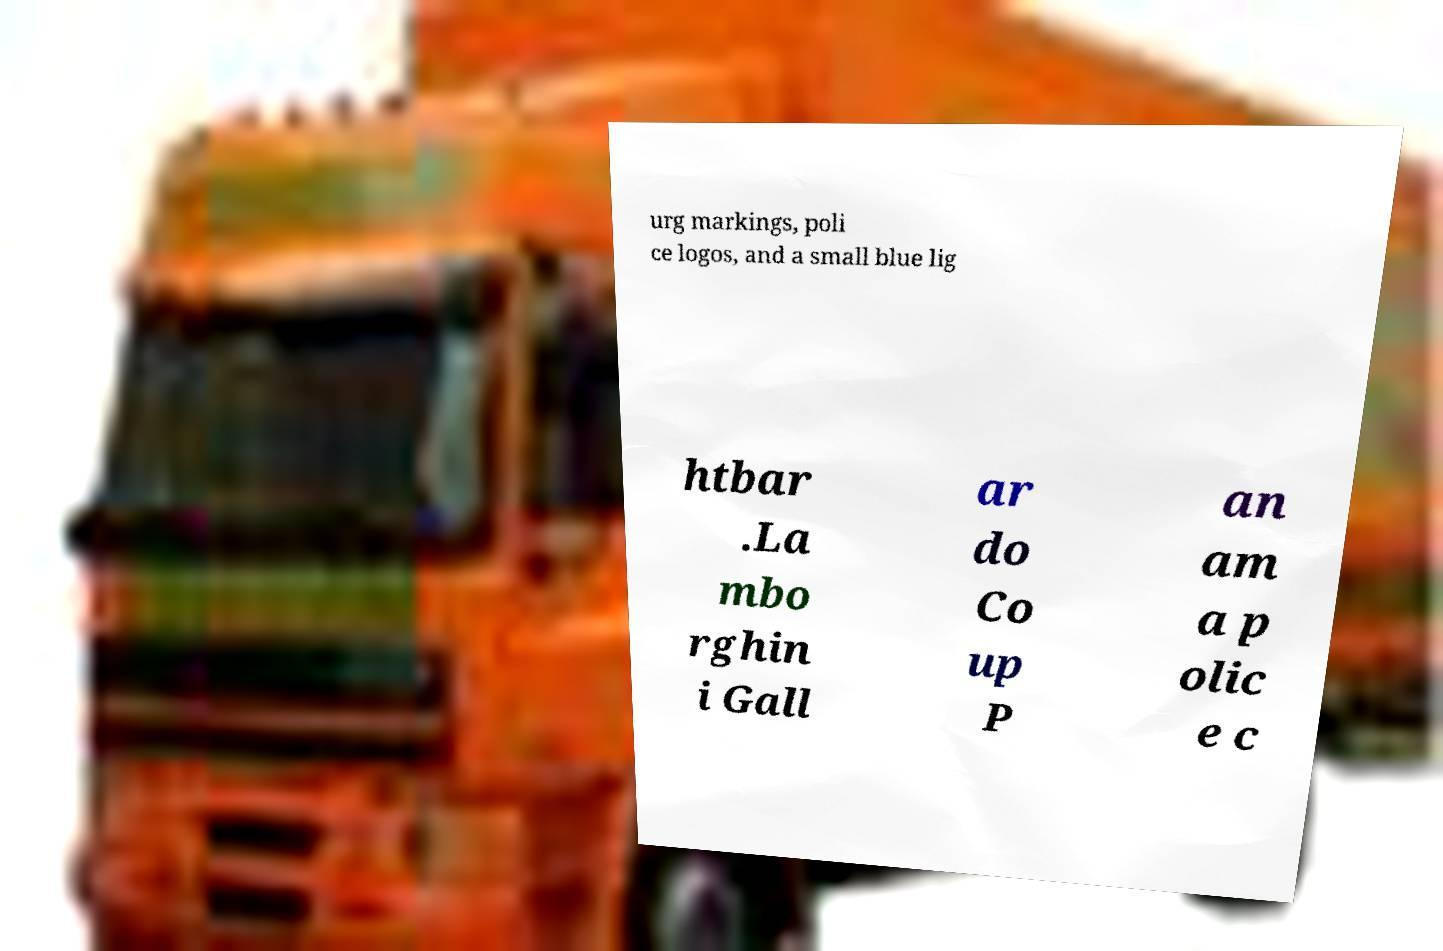Please identify and transcribe the text found in this image. urg markings, poli ce logos, and a small blue lig htbar .La mbo rghin i Gall ar do Co up P an am a p olic e c 